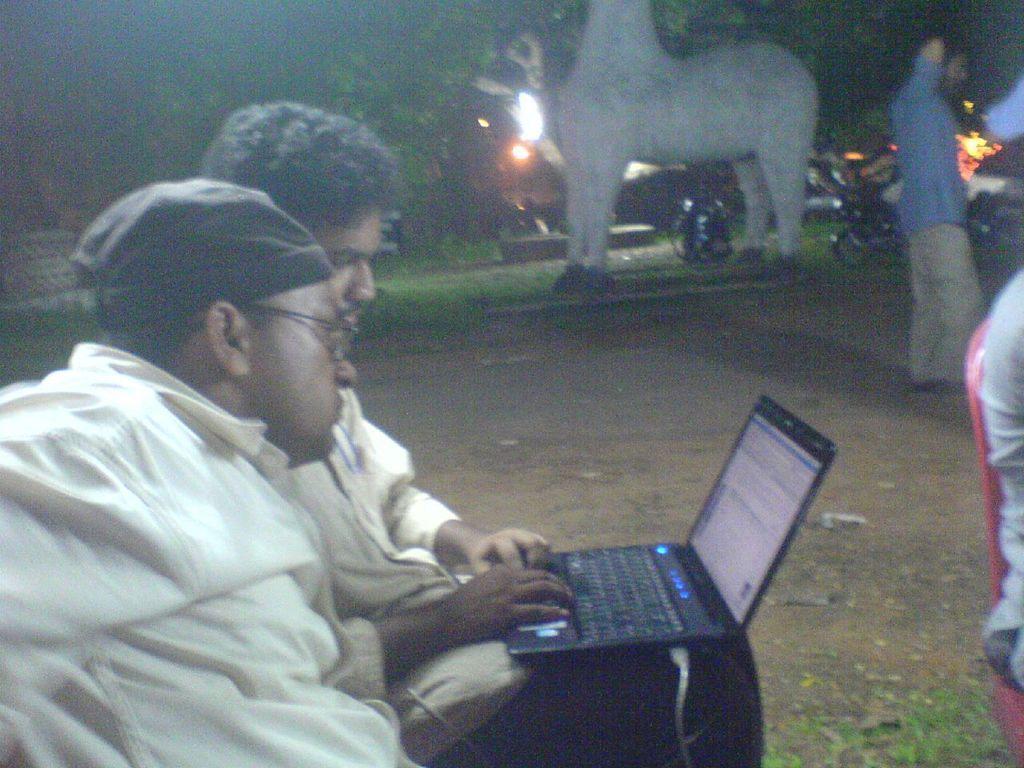In one or two sentences, can you explain what this image depicts? In this image there is a man working with the laptop. Beside him there is another man who is looking in to the screen. In the background there is a tree. Beside the tree there are lights. On the right side there is a person sitting in the chair. In the background there are bikes parked on the ground. In the middle there is an animal on the floor. 